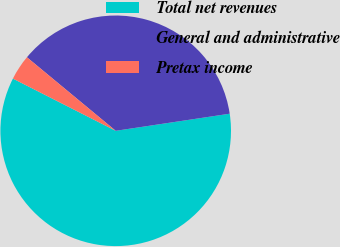Convert chart to OTSL. <chart><loc_0><loc_0><loc_500><loc_500><pie_chart><fcel>Total net revenues<fcel>General and administrative<fcel>Pretax income<nl><fcel>59.85%<fcel>36.62%<fcel>3.53%<nl></chart> 